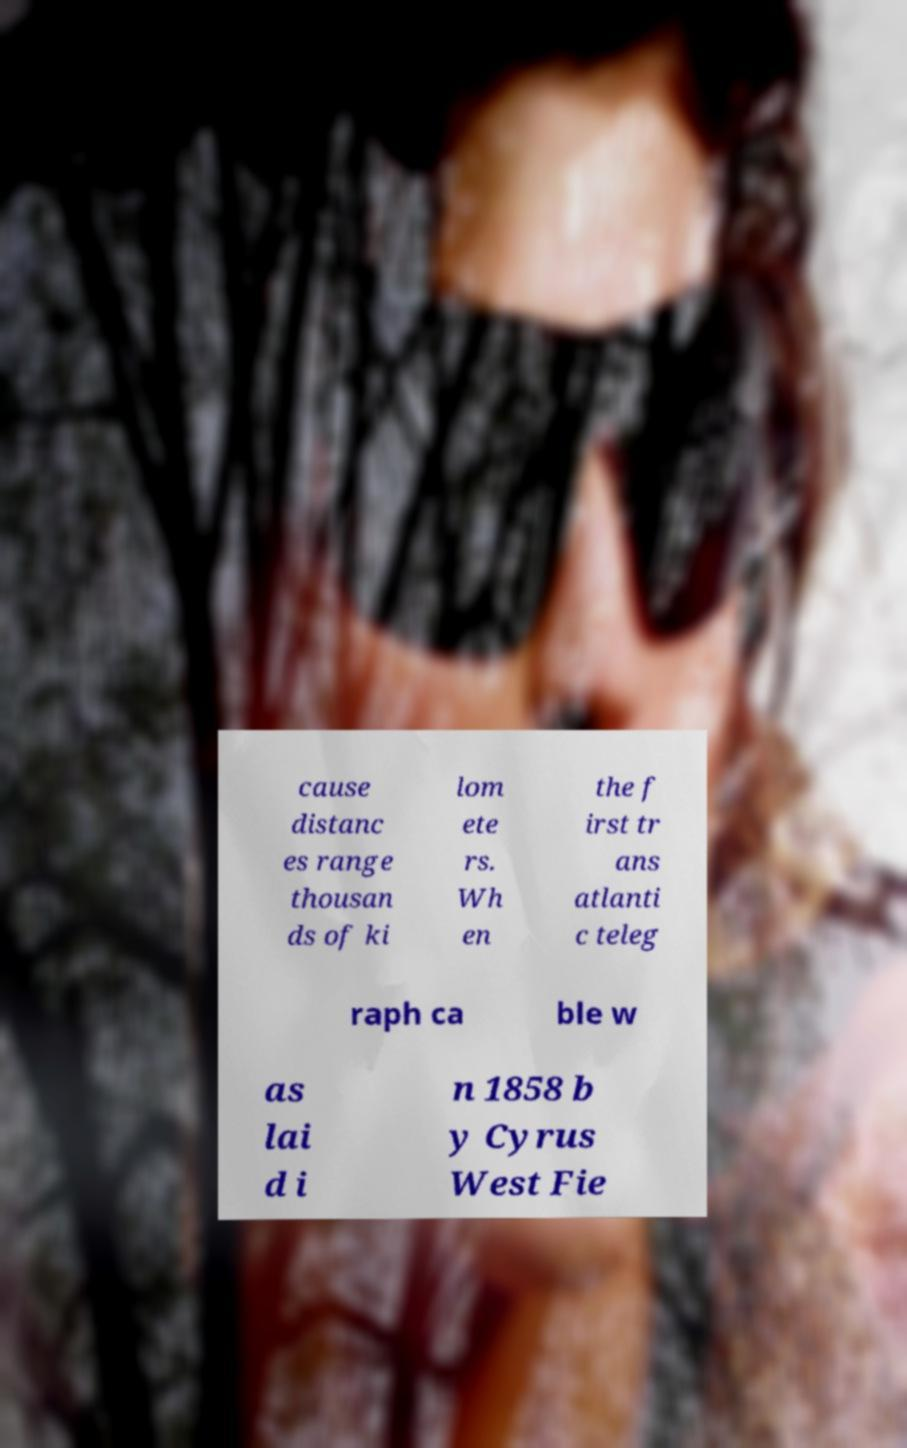Can you accurately transcribe the text from the provided image for me? cause distanc es range thousan ds of ki lom ete rs. Wh en the f irst tr ans atlanti c teleg raph ca ble w as lai d i n 1858 b y Cyrus West Fie 